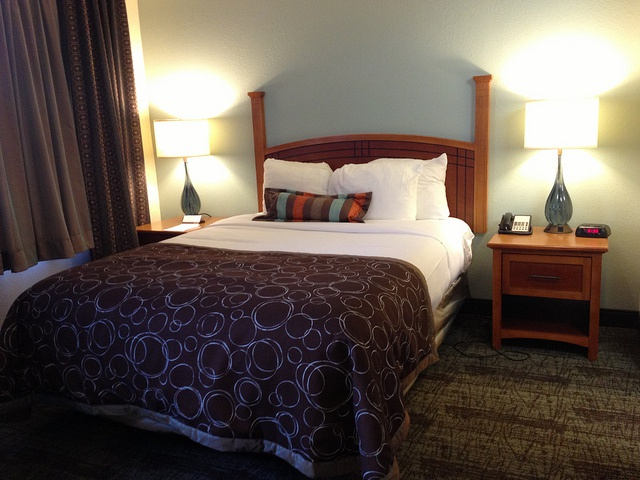Describe the objects in this image and their specific colors. I can see bed in purple, black, maroon, beige, and tan tones and clock in purple, black, gray, and maroon tones in this image. 